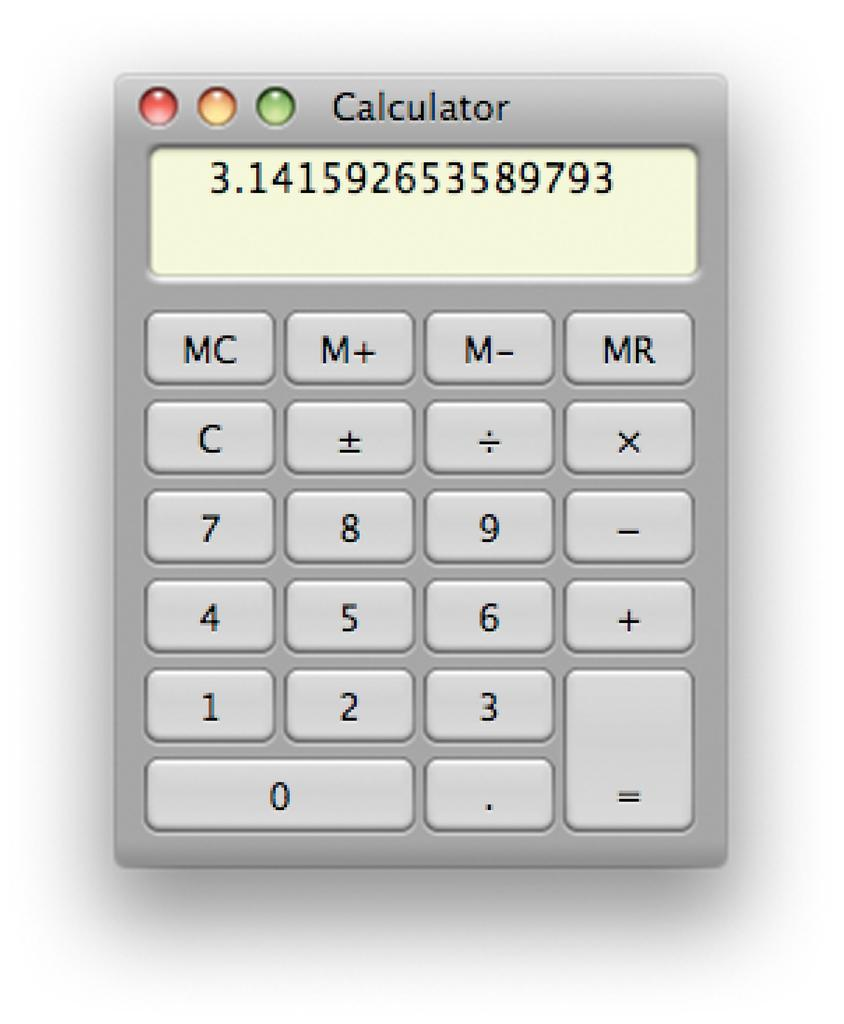<image>
Share a concise interpretation of the image provided. A calculator displays a number that goes on from 3.14 to several more decimal places. 